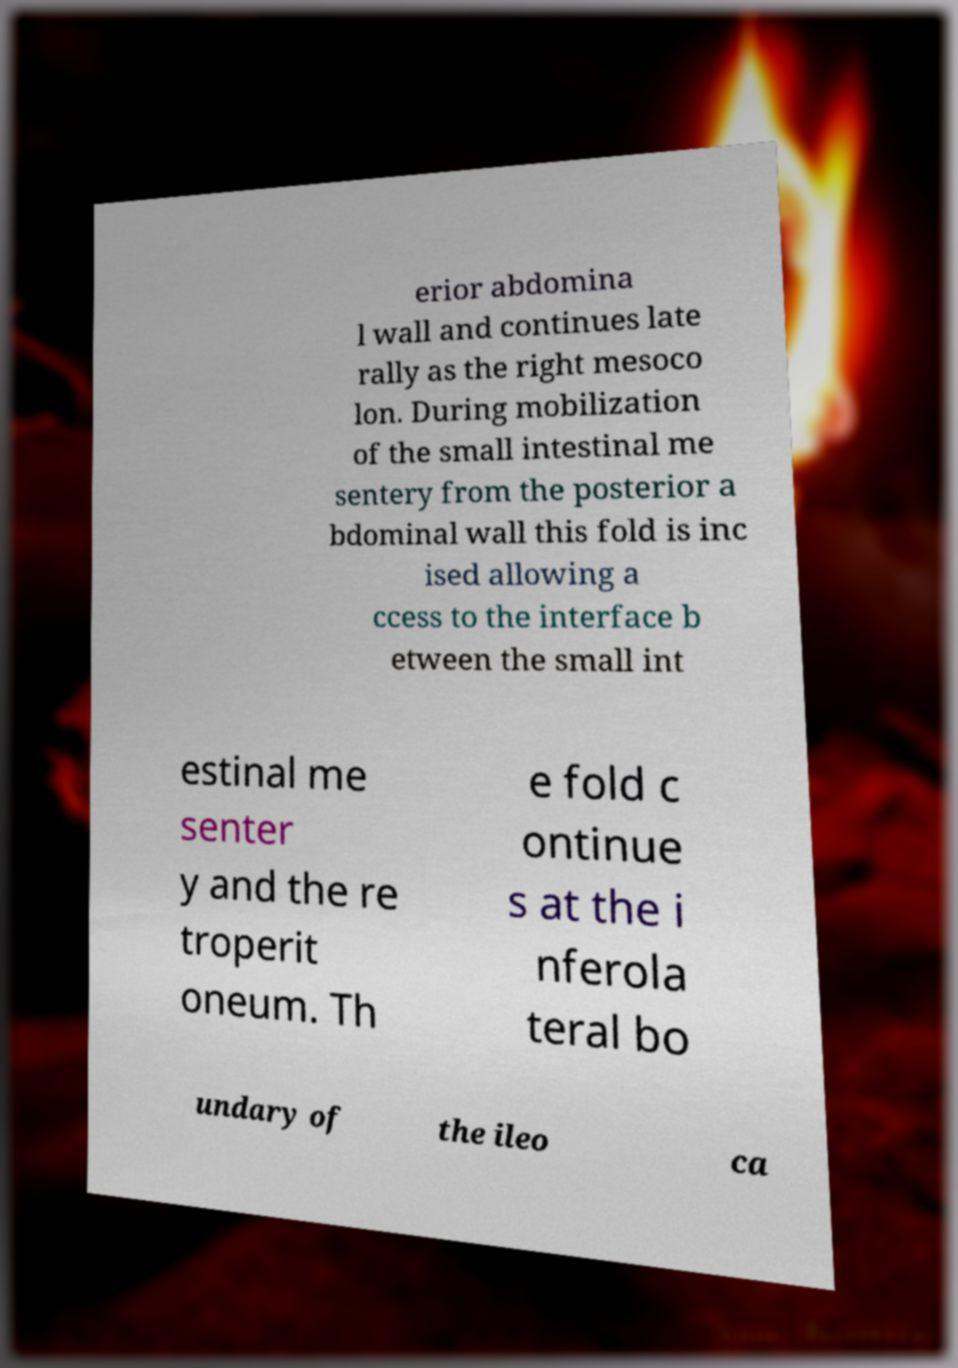For documentation purposes, I need the text within this image transcribed. Could you provide that? erior abdomina l wall and continues late rally as the right mesoco lon. During mobilization of the small intestinal me sentery from the posterior a bdominal wall this fold is inc ised allowing a ccess to the interface b etween the small int estinal me senter y and the re troperit oneum. Th e fold c ontinue s at the i nferola teral bo undary of the ileo ca 